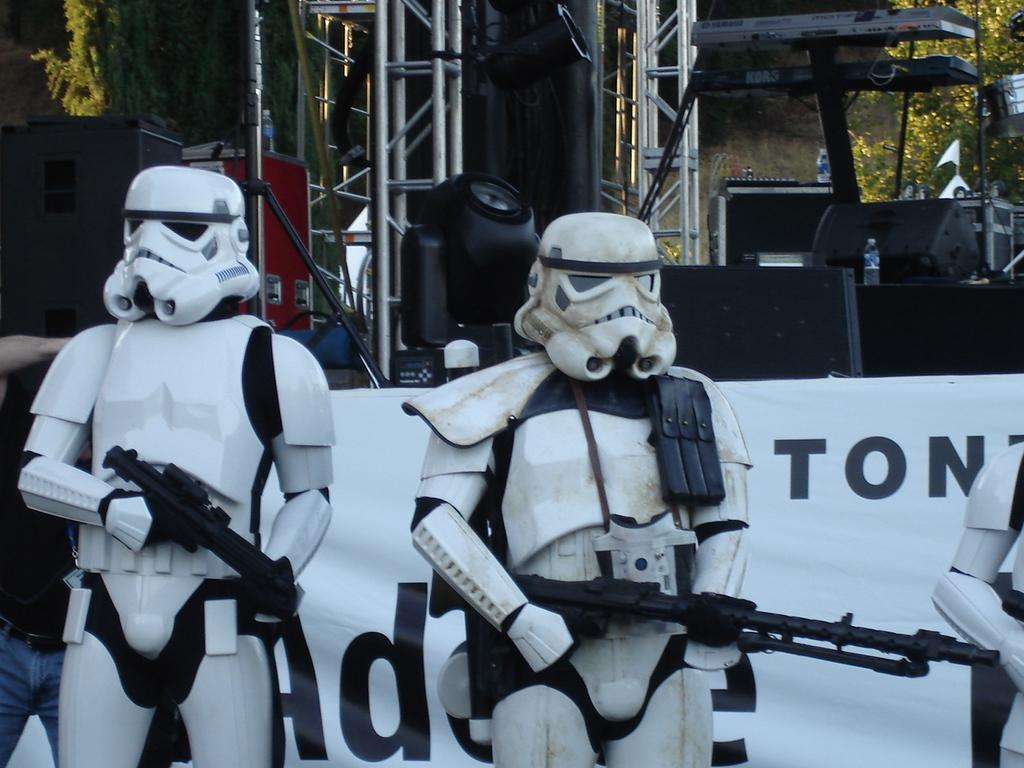What type of objects can be seen in the image? There are statues in the image. What are the statues wearing? The statues are wearing helmets. What are the statues holding? The statues are holding guns. What can be seen in the background of the image? There is a banner, poles, trees, and bottles in the background of the image. Where is the vase located in the image? There is no vase present in the image. What type of drawer can be seen in the image? There is no drawer present in the image. 